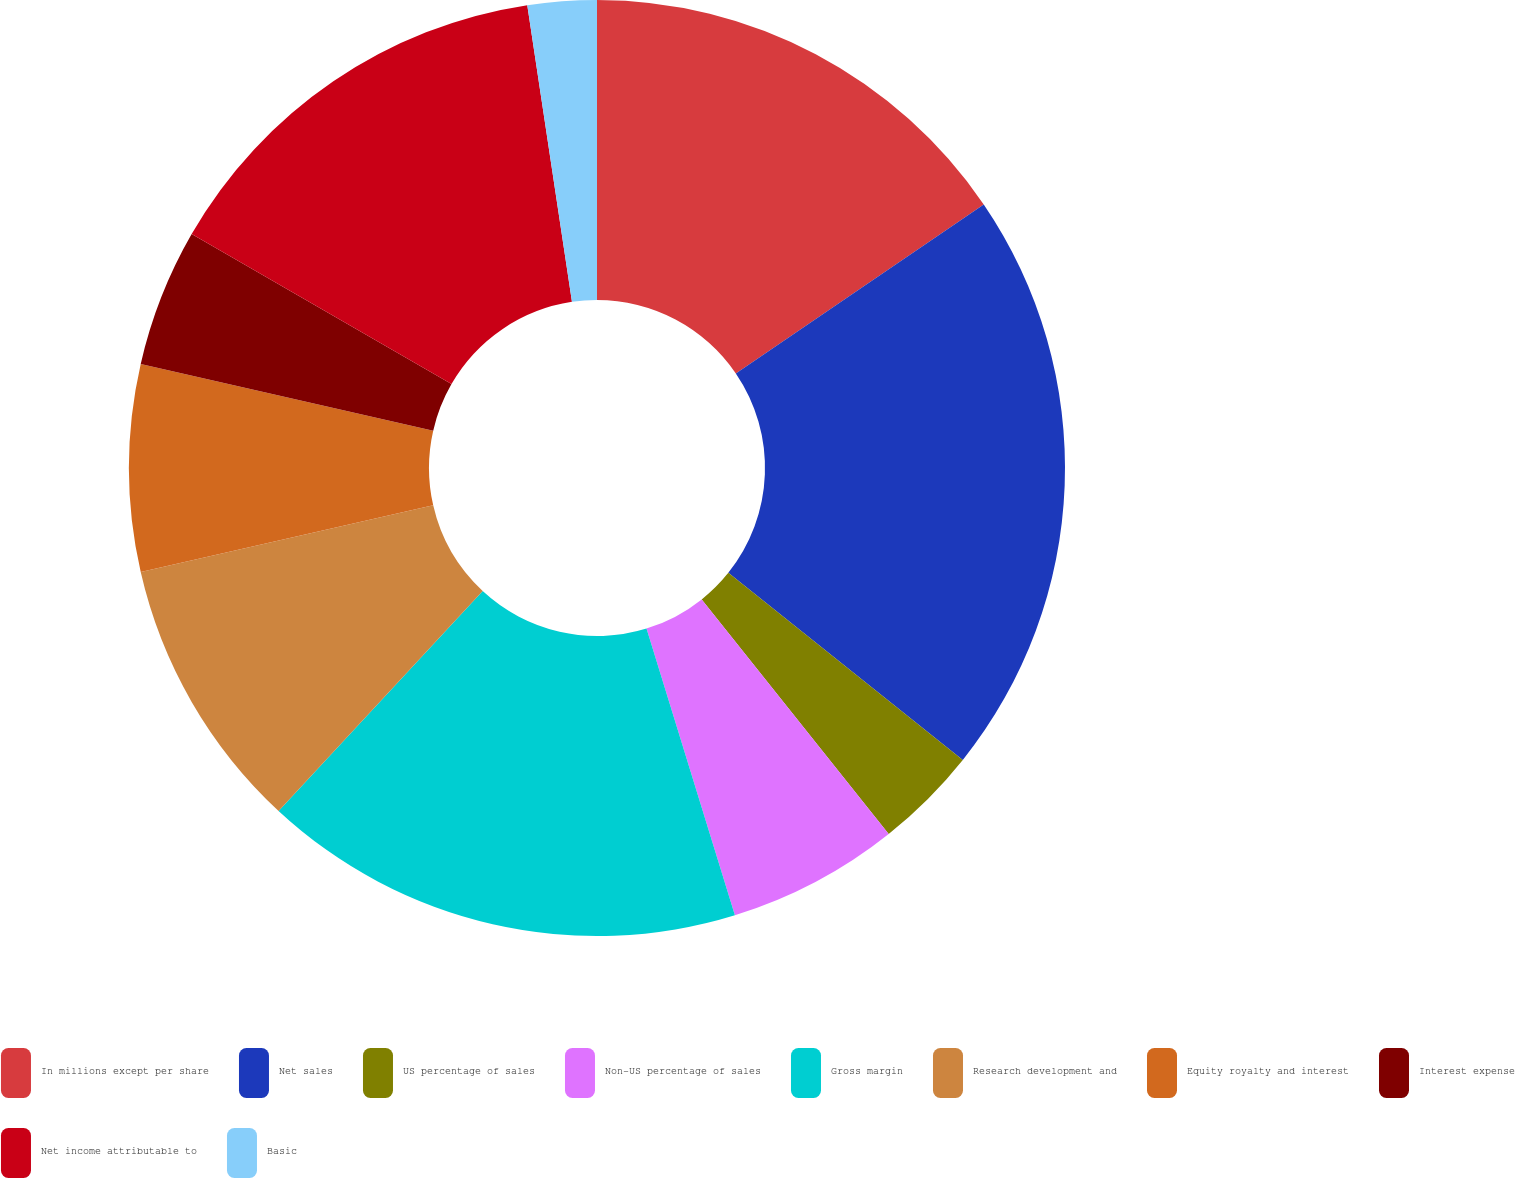Convert chart to OTSL. <chart><loc_0><loc_0><loc_500><loc_500><pie_chart><fcel>In millions except per share<fcel>Net sales<fcel>US percentage of sales<fcel>Non-US percentage of sales<fcel>Gross margin<fcel>Research development and<fcel>Equity royalty and interest<fcel>Interest expense<fcel>Net income attributable to<fcel>Basic<nl><fcel>15.48%<fcel>20.24%<fcel>3.57%<fcel>5.95%<fcel>16.67%<fcel>9.52%<fcel>7.14%<fcel>4.76%<fcel>14.29%<fcel>2.38%<nl></chart> 